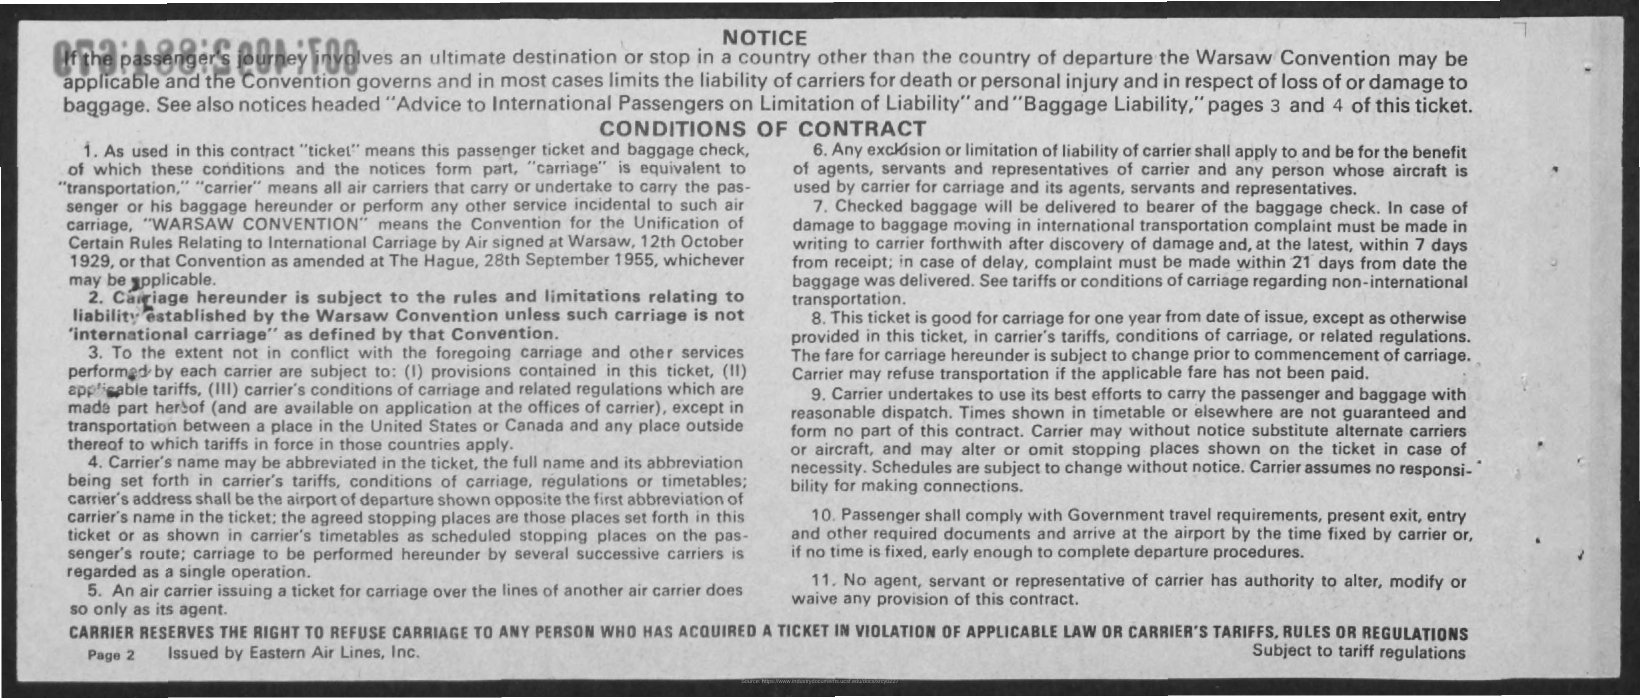What is the first title in the document?
Provide a succinct answer. NOTICE. What is the second title in the document?
Offer a terse response. Conditions of Contract. What is the Page Number?
Your response must be concise. 2. The notice is issued by which company?
Your answer should be very brief. EASTERN AIR LINES, INC. 